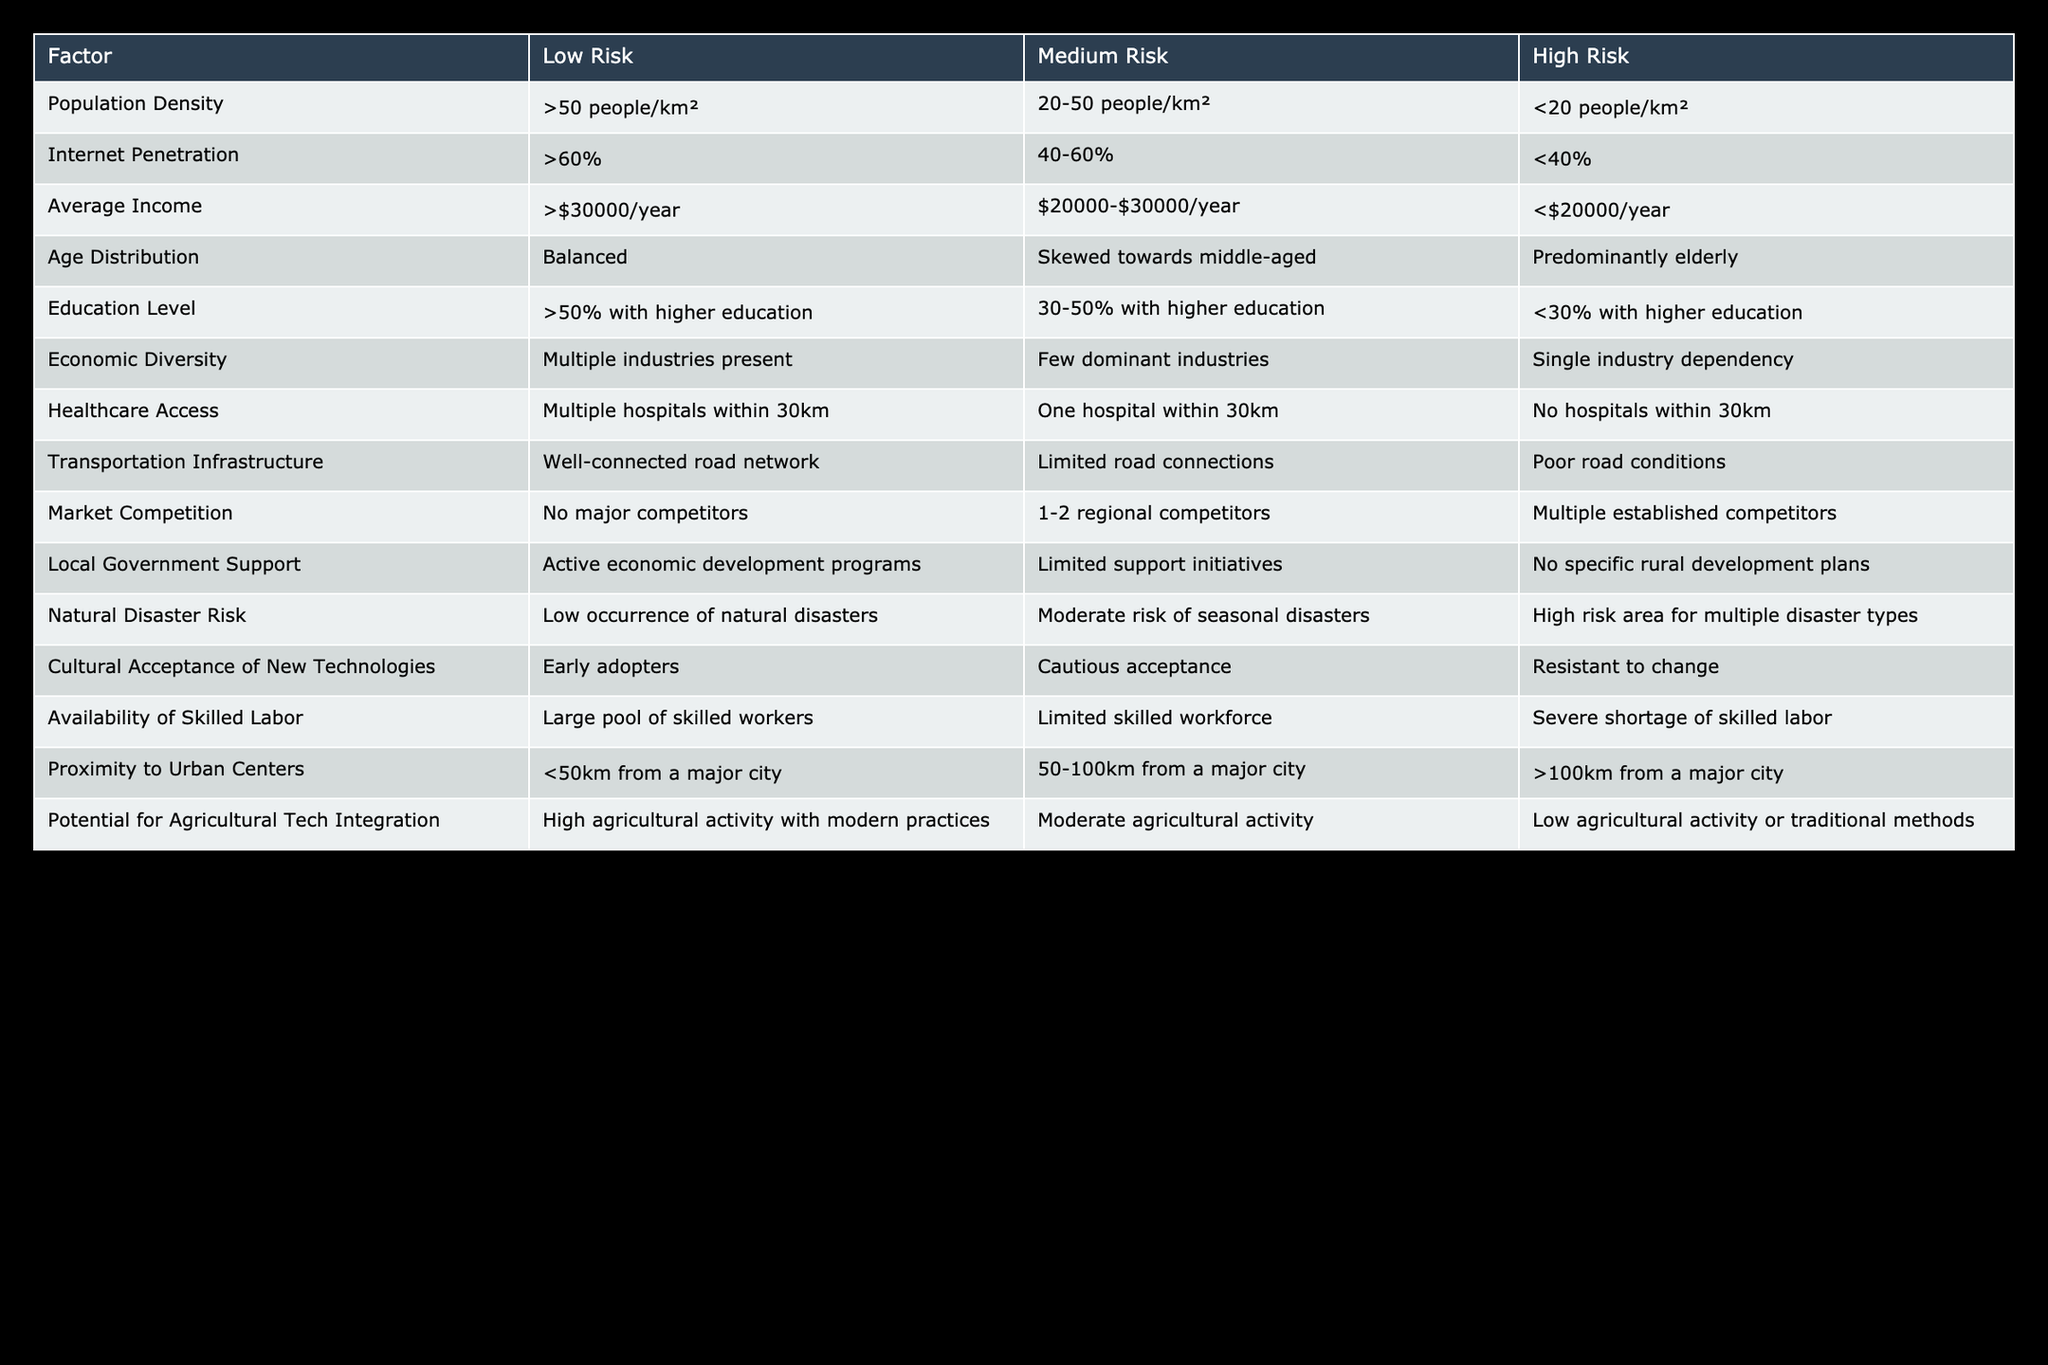What is the population density range for low-risk areas? The table specifies that low-risk areas have a population density of more than 50 people per square kilometer. This criterion defines the threshold for identifying low-risk zones based on population density.
Answer: More than 50 people/km² How many factors indicate high risk for economic diversity? The only factor that qualifies as high risk for economic diversity is "Single industry dependency," making it one out of seven factors in the table that would fit this criterion.
Answer: 1 Is there local government support in areas categorized as high risk? According to the table, high-risk areas have "No specific rural development plans," which indicates a lack of local government support. Therefore, in high-risk areas, local government support is absent.
Answer: No Which category of average income is associated with medium-risk areas? The table indicates that medium-risk areas have an average income ranging from 20,000 to 30,000 dollars per year. This information can be directly retrieved from the table's 'Average Income' row under the 'Medium Risk' column.
Answer: $20,000-$30,000/year What are the implications of transportation infrastructure when considering expansion into low-risk zones? For low-risk zones, the table indicates the presence of "Well-connected road network." This suggests that areas classified as low risk have robust transportation systems that facilitate access and logistics, which is favorable for business expansion.
Answer: Well-connected road network If an area has a population density of 25 people/km² and an internet penetration of 45%, what is its risk assessment for these factors? Based on the table, a population density of 25 people/km² falls into the high-risk category (<20 people/km²), while an internet penetration of 45% is categorized as medium risk (40-60%). This means the overall risk assessment of the area would be primarily guided by the high population density risk score, which is more severe.
Answer: High Risk (due to population density) In terms of agricultural tech integration, what risk is associated with low agricultural activity? The table shows that areas with low agricultural activity or traditional methods fall into the low-risk category for agricultural tech integration. Therefore, such areas lack modern agricultural practices that can support the introduction of agricultural technologies.
Answer: Low agricultural activity or traditional methods How does the age distribution factor into the risk assessment in rural expansions? The table categorizes age distribution as balanced (low risk), skewed towards middle-aged (medium risk), or predominantly elderly (high risk). A balanced age distribution means the population is diverse in terms of age, which typically poses lower risks for expansion compared to areas skewed towards specific age demographics.
Answer: Balanced (low risk) 